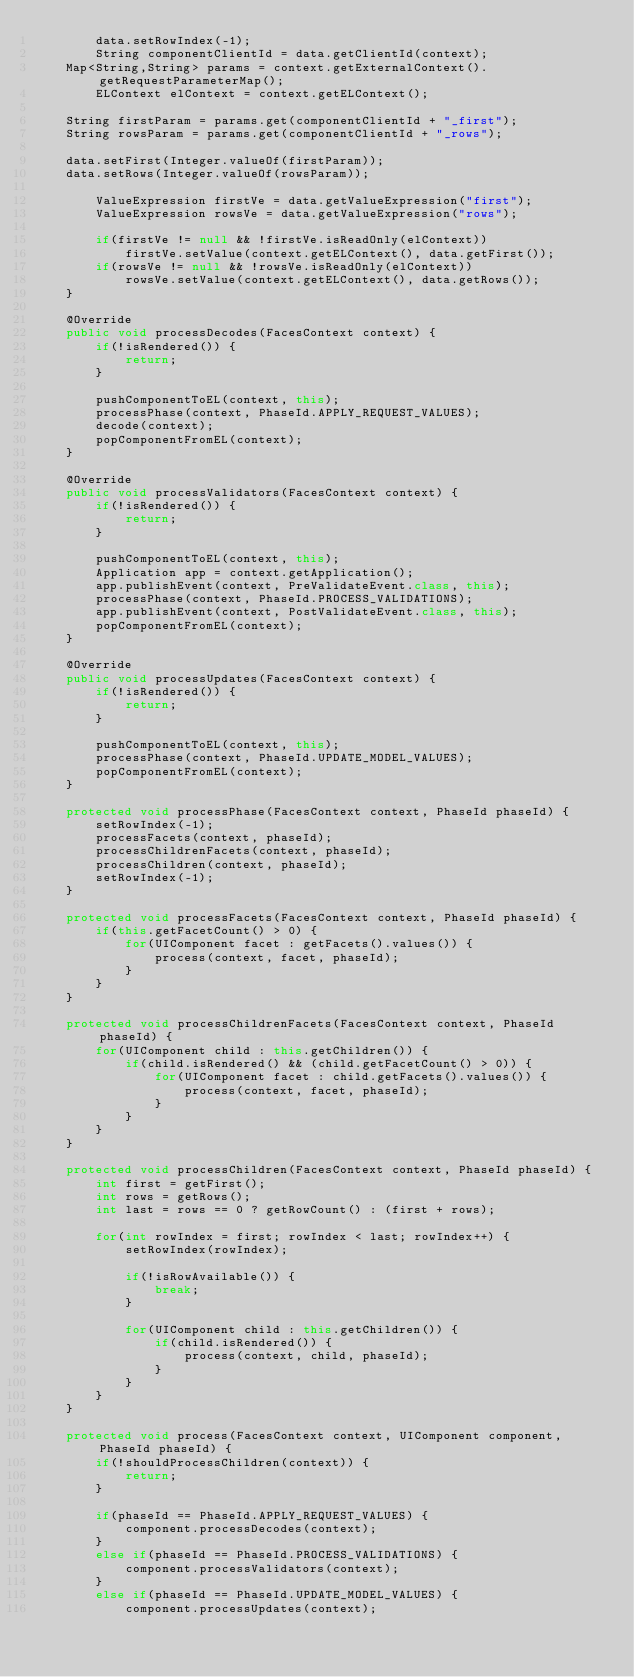Convert code to text. <code><loc_0><loc_0><loc_500><loc_500><_Java_>        data.setRowIndex(-1);
        String componentClientId = data.getClientId(context);
		Map<String,String> params = context.getExternalContext().getRequestParameterMap();
        ELContext elContext = context.getELContext();
        
		String firstParam = params.get(componentClientId + "_first");
		String rowsParam = params.get(componentClientId + "_rows");

		data.setFirst(Integer.valueOf(firstParam));
		data.setRows(Integer.valueOf(rowsParam));
        
        ValueExpression firstVe = data.getValueExpression("first");
        ValueExpression rowsVe = data.getValueExpression("rows");

        if(firstVe != null && !firstVe.isReadOnly(elContext))
            firstVe.setValue(context.getELContext(), data.getFirst());
        if(rowsVe != null && !rowsVe.isReadOnly(elContext))
            rowsVe.setValue(context.getELContext(), data.getRows());
    }
    
    @Override
    public void processDecodes(FacesContext context) {
        if(!isRendered()) {
            return;
        }
        
        pushComponentToEL(context, this);
        processPhase(context, PhaseId.APPLY_REQUEST_VALUES);
        decode(context);
        popComponentFromEL(context);
    }
    
    @Override
    public void processValidators(FacesContext context) {
        if(!isRendered()) {
            return;
        }
        
        pushComponentToEL(context, this);
        Application app = context.getApplication();
        app.publishEvent(context, PreValidateEvent.class, this);
        processPhase(context, PhaseId.PROCESS_VALIDATIONS);
        app.publishEvent(context, PostValidateEvent.class, this);
        popComponentFromEL(context);
    }
    
    @Override
    public void processUpdates(FacesContext context) {
        if(!isRendered()) {
            return;
        }
        
        pushComponentToEL(context, this);
        processPhase(context, PhaseId.UPDATE_MODEL_VALUES);
        popComponentFromEL(context);
    }
    
    protected void processPhase(FacesContext context, PhaseId phaseId) {
        setRowIndex(-1);
        processFacets(context, phaseId);
        processChildrenFacets(context, phaseId);
        processChildren(context, phaseId);
        setRowIndex(-1);
    }
    
    protected void processFacets(FacesContext context, PhaseId phaseId) {
        if(this.getFacetCount() > 0) {
            for(UIComponent facet : getFacets().values()) {
                process(context, facet, phaseId);
            }
        }
    }
    
    protected void processChildrenFacets(FacesContext context, PhaseId phaseId) {
        for(UIComponent child : this.getChildren()) {
            if(child.isRendered() && (child.getFacetCount() > 0)) {
                for(UIComponent facet : child.getFacets().values()) {
                    process(context, facet, phaseId);
                }
            }
        }
    }
    
    protected void processChildren(FacesContext context, PhaseId phaseId) {
        int first = getFirst();
        int rows = getRows();
        int last = rows == 0 ? getRowCount() : (first + rows);
        
        for(int rowIndex = first; rowIndex < last; rowIndex++) {
            setRowIndex(rowIndex);

            if(!isRowAvailable()) {
                break;
            }
            
            for(UIComponent child : this.getChildren()) {
                if(child.isRendered()) {
                    process(context, child, phaseId);
                }
            }            
        }
    }
    
    protected void process(FacesContext context, UIComponent component, PhaseId phaseId) {
        if(!shouldProcessChildren(context)) {
            return;
        }
        
        if(phaseId == PhaseId.APPLY_REQUEST_VALUES) {
            component.processDecodes(context);
        }
        else if(phaseId == PhaseId.PROCESS_VALIDATIONS) {
            component.processValidators(context);
        }
        else if(phaseId == PhaseId.UPDATE_MODEL_VALUES) {
            component.processUpdates(context);</code> 